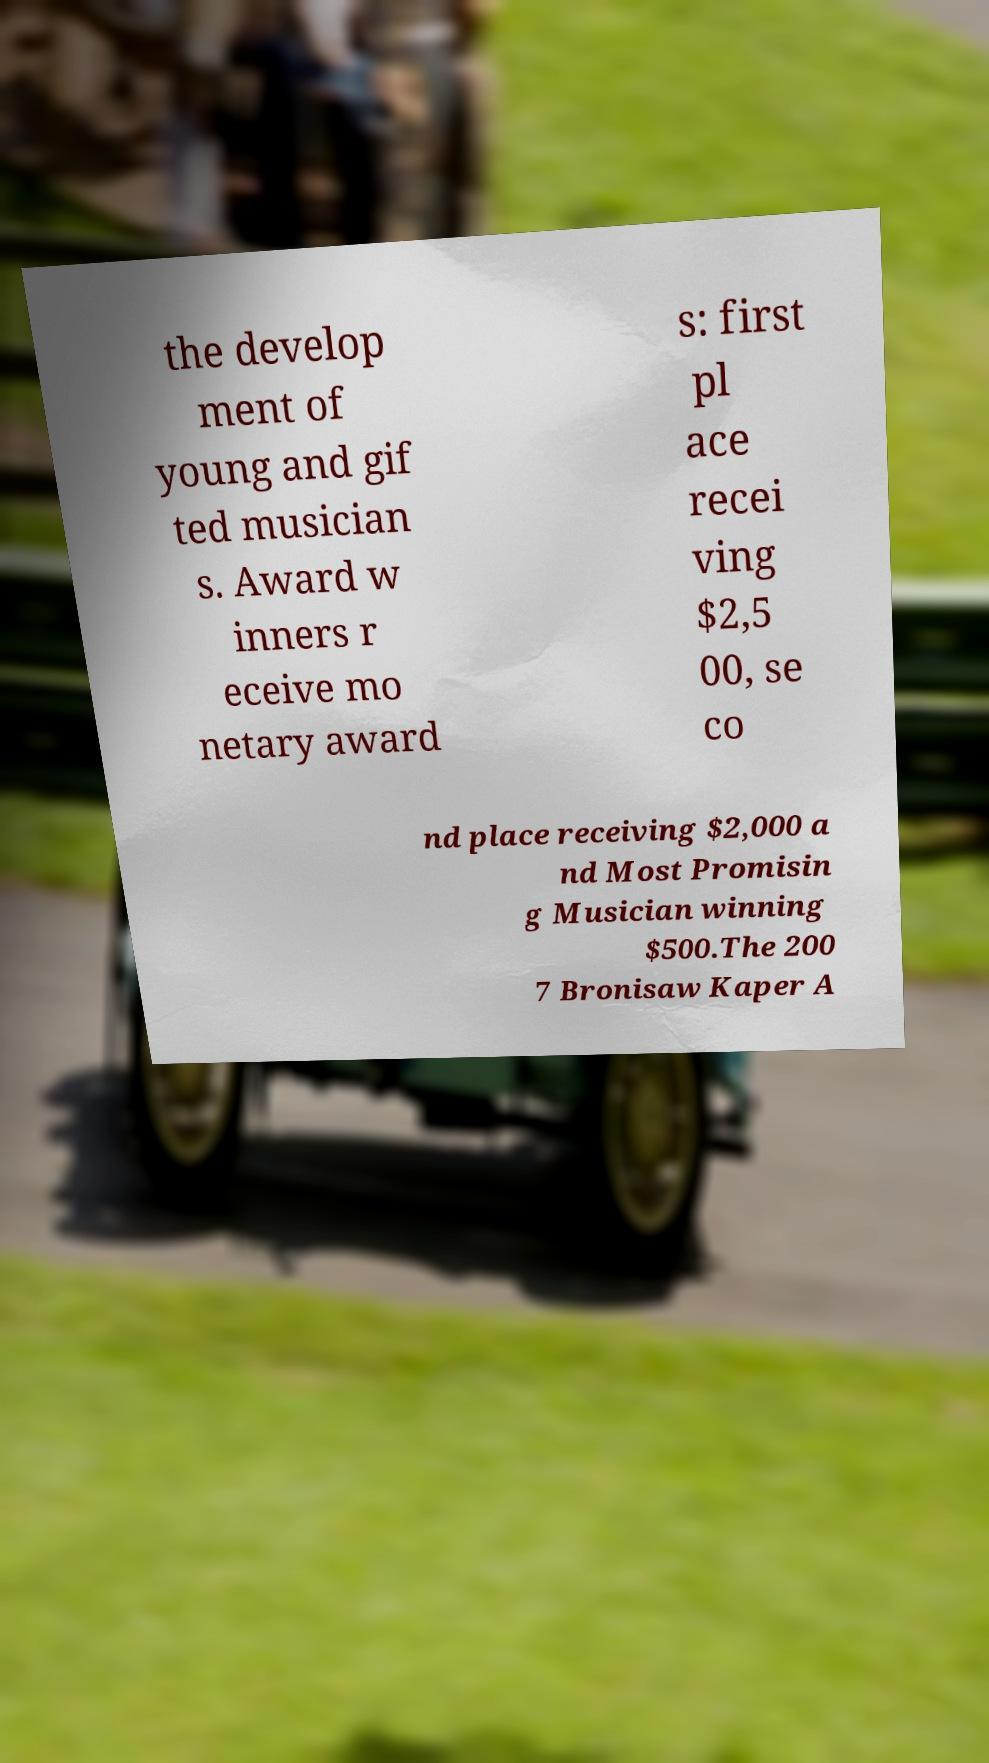Could you assist in decoding the text presented in this image and type it out clearly? the develop ment of young and gif ted musician s. Award w inners r eceive mo netary award s: first pl ace recei ving $2,5 00, se co nd place receiving $2,000 a nd Most Promisin g Musician winning $500.The 200 7 Bronisaw Kaper A 